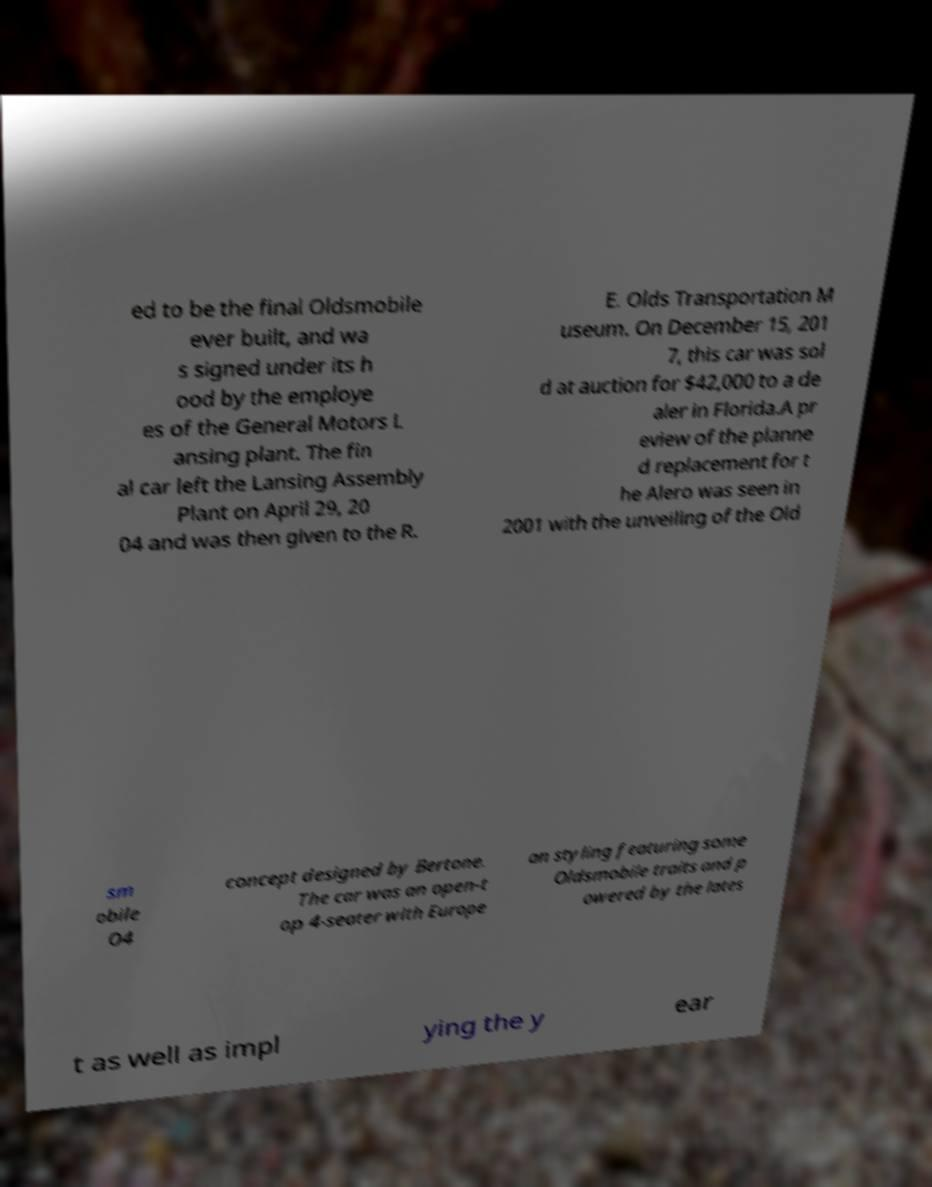What messages or text are displayed in this image? I need them in a readable, typed format. ed to be the final Oldsmobile ever built, and wa s signed under its h ood by the employe es of the General Motors L ansing plant. The fin al car left the Lansing Assembly Plant on April 29, 20 04 and was then given to the R. E. Olds Transportation M useum. On December 15, 201 7, this car was sol d at auction for $42,000 to a de aler in Florida.A pr eview of the planne d replacement for t he Alero was seen in 2001 with the unveiling of the Old sm obile O4 concept designed by Bertone. The car was an open-t op 4-seater with Europe an styling featuring some Oldsmobile traits and p owered by the lates t as well as impl ying the y ear 